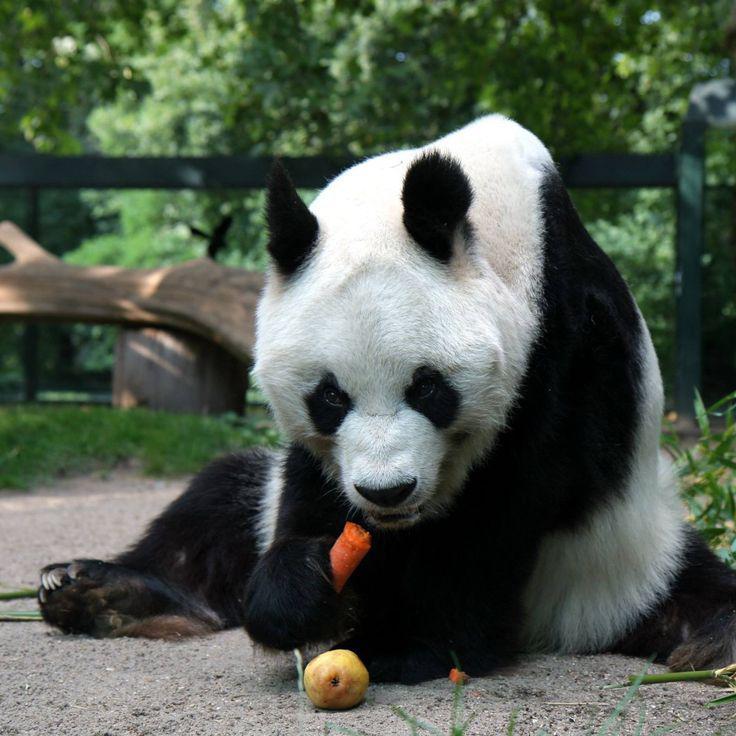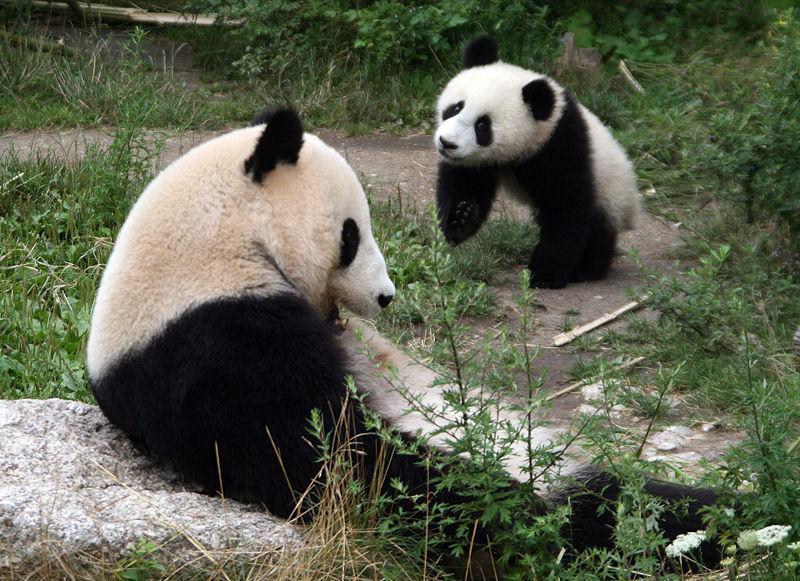The first image is the image on the left, the second image is the image on the right. For the images displayed, is the sentence "The right image shows two pandas." factually correct? Answer yes or no. Yes. 